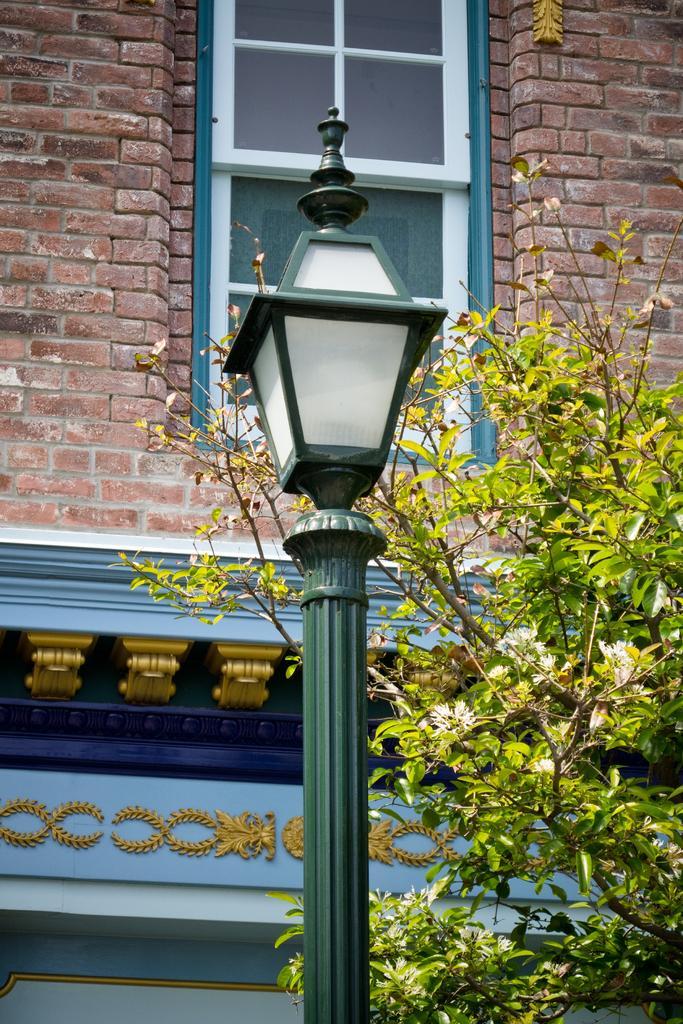Please provide a concise description of this image. In the center of the image, we can see a light and in the background, there is a tree and we can see a window on the building. 